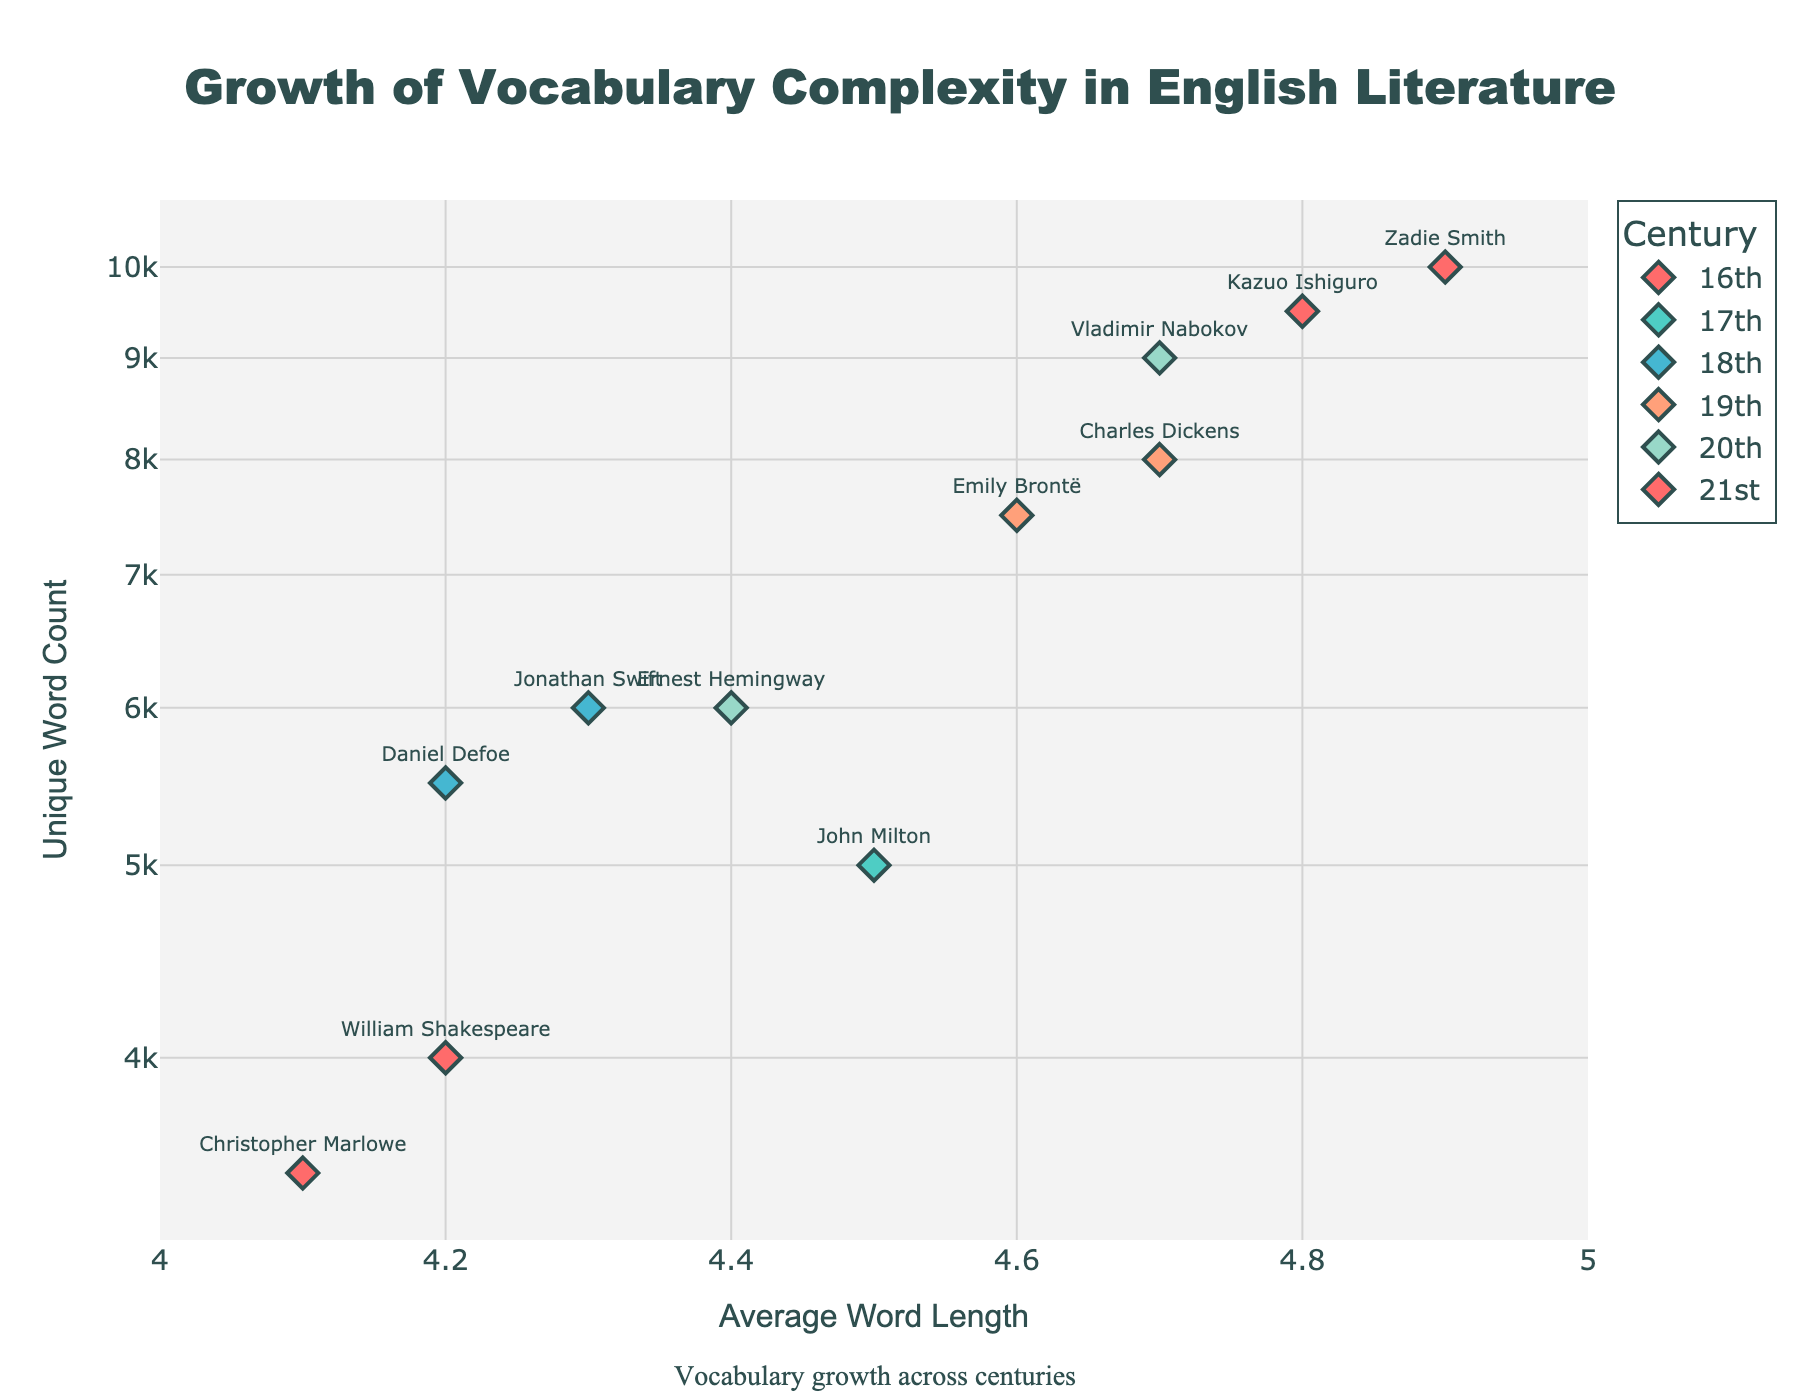What is the title of the plot? The title is displayed at the top center of the plot. It reads: "Growth of Vocabulary Complexity in English Literature".
Answer: Growth of Vocabulary Complexity in English Literature What is the range of the y-axis in the plot? The y-axis represents the 'Unique Word Count' on a log scale. The range is defined by the minimum and maximum visible values, from a little below 1,000 to a little above 100,000.
Answer: 1,000 to 100,000 Which century has the text with the highest average word length? By looking at the x-axis, which measures average word length, the points furthest to the right belong to the 21st century.
Answer: 21st century How many unique works are represented from the 19th century? The legend cites each century, and there are two markers from the 19th century: one for Charles Dickens and one for Emily Brontë.
Answer: 2 What are the unique word counts for the works from the 20th century? The figure displays markers for the 20th century with unique word counts along the y-axis for Ernest Hemingway's "The Old Man and the Sea" (6,000) and Vladimir Nabokov's "Lolita" (9,000).
Answer: 6,000, 9,000 Which work has an average word length of 4.8? By examining the x-axis for the value 4.8 and looking at corresponding markers and their labels, we find "Never Let Me Go" by Kazuo Ishiguro from the 21st century.
Answer: Never Let Me Go Which century shows the greatest variation in unique word count? The century with the widest spread of values on the y-axis signals the greatest variation. The 19th century ranges from 7,500 to 8,000, while other centuries have similar overall ranges.
Answer: 20th century Who is the author with the highest number of unique words? The highest point on the y-axis is labeled with the author's name. This corresponds to Vladimir Nabokov's "Lolita" with 9,000 unique words.
Answer: Vladimir Nabokov Compare the unique word counts of "Hamlet" and "Doctor Faustus". Which has more? "Hamlet" by William Shakespeare and "Doctor Faustus" by Christopher Marlowe can be compared along the y-axis; Hamlet is marked at 4,000 and Doctor Faustus at 3,500. Thus, Hamlet has more.
Answer: Hamlet Considering works from the 18th century, what is the difference in average word length between "Gulliver's Travels" and "Robinson Crusoe"? Referencing the x-axis, "Gulliver's Travels" has an average word length of 4.3 and "Robinson Crusoe" of 4.2; calculating the difference, 4.3 - 4.2 equals 0.1.
Answer: 0.1 